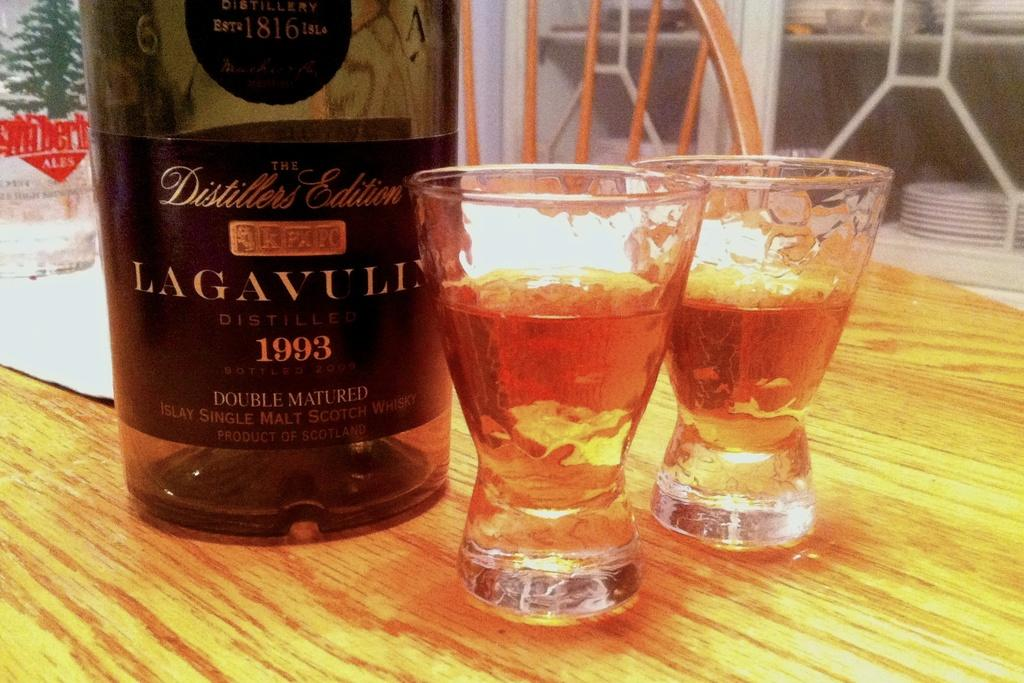<image>
Provide a brief description of the given image. A bottle of single malt scotch from 1993 is poured into two shot glasses. 